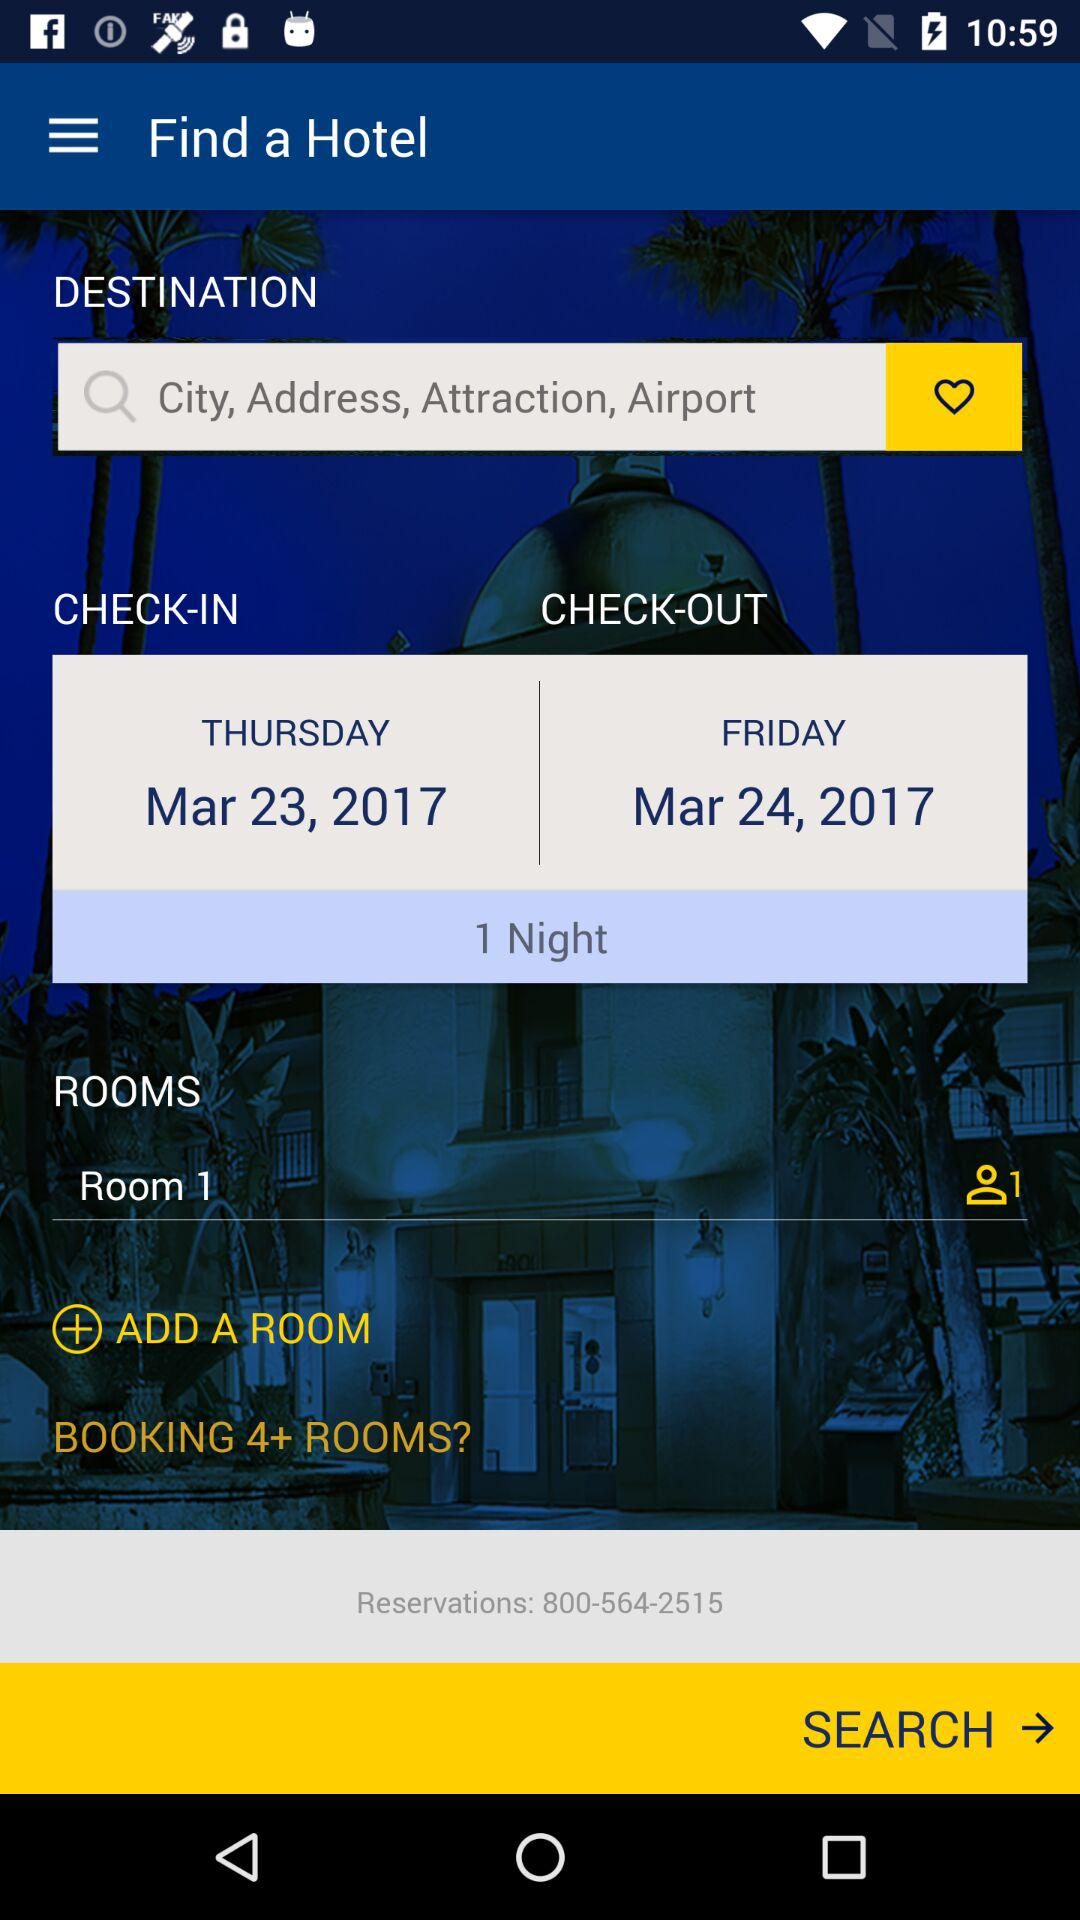How many rooms are selected?
Answer the question using a single word or phrase. 1 